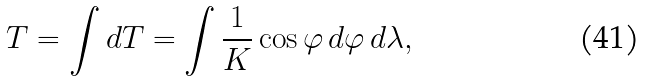<formula> <loc_0><loc_0><loc_500><loc_500>T = \int d T = \int { \frac { 1 } { K } } \cos \varphi \, d \varphi \, d \lambda ,</formula> 